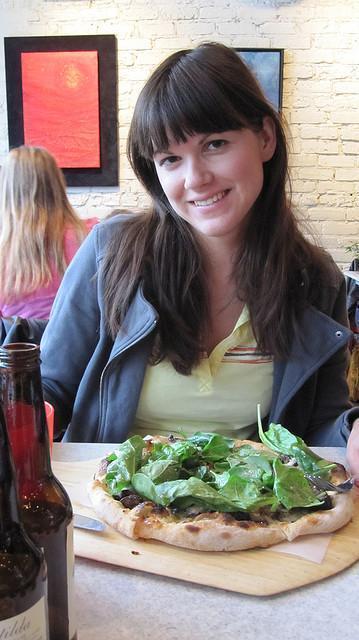What is adorning the pizza?
Indicate the correct choice and explain in the format: 'Answer: answer
Rationale: rationale.'
Options: Cherries, anchovies, meatballs, lettuce. Answer: lettuce.
Rationale: There are whole green leaves on top of the pizza. 